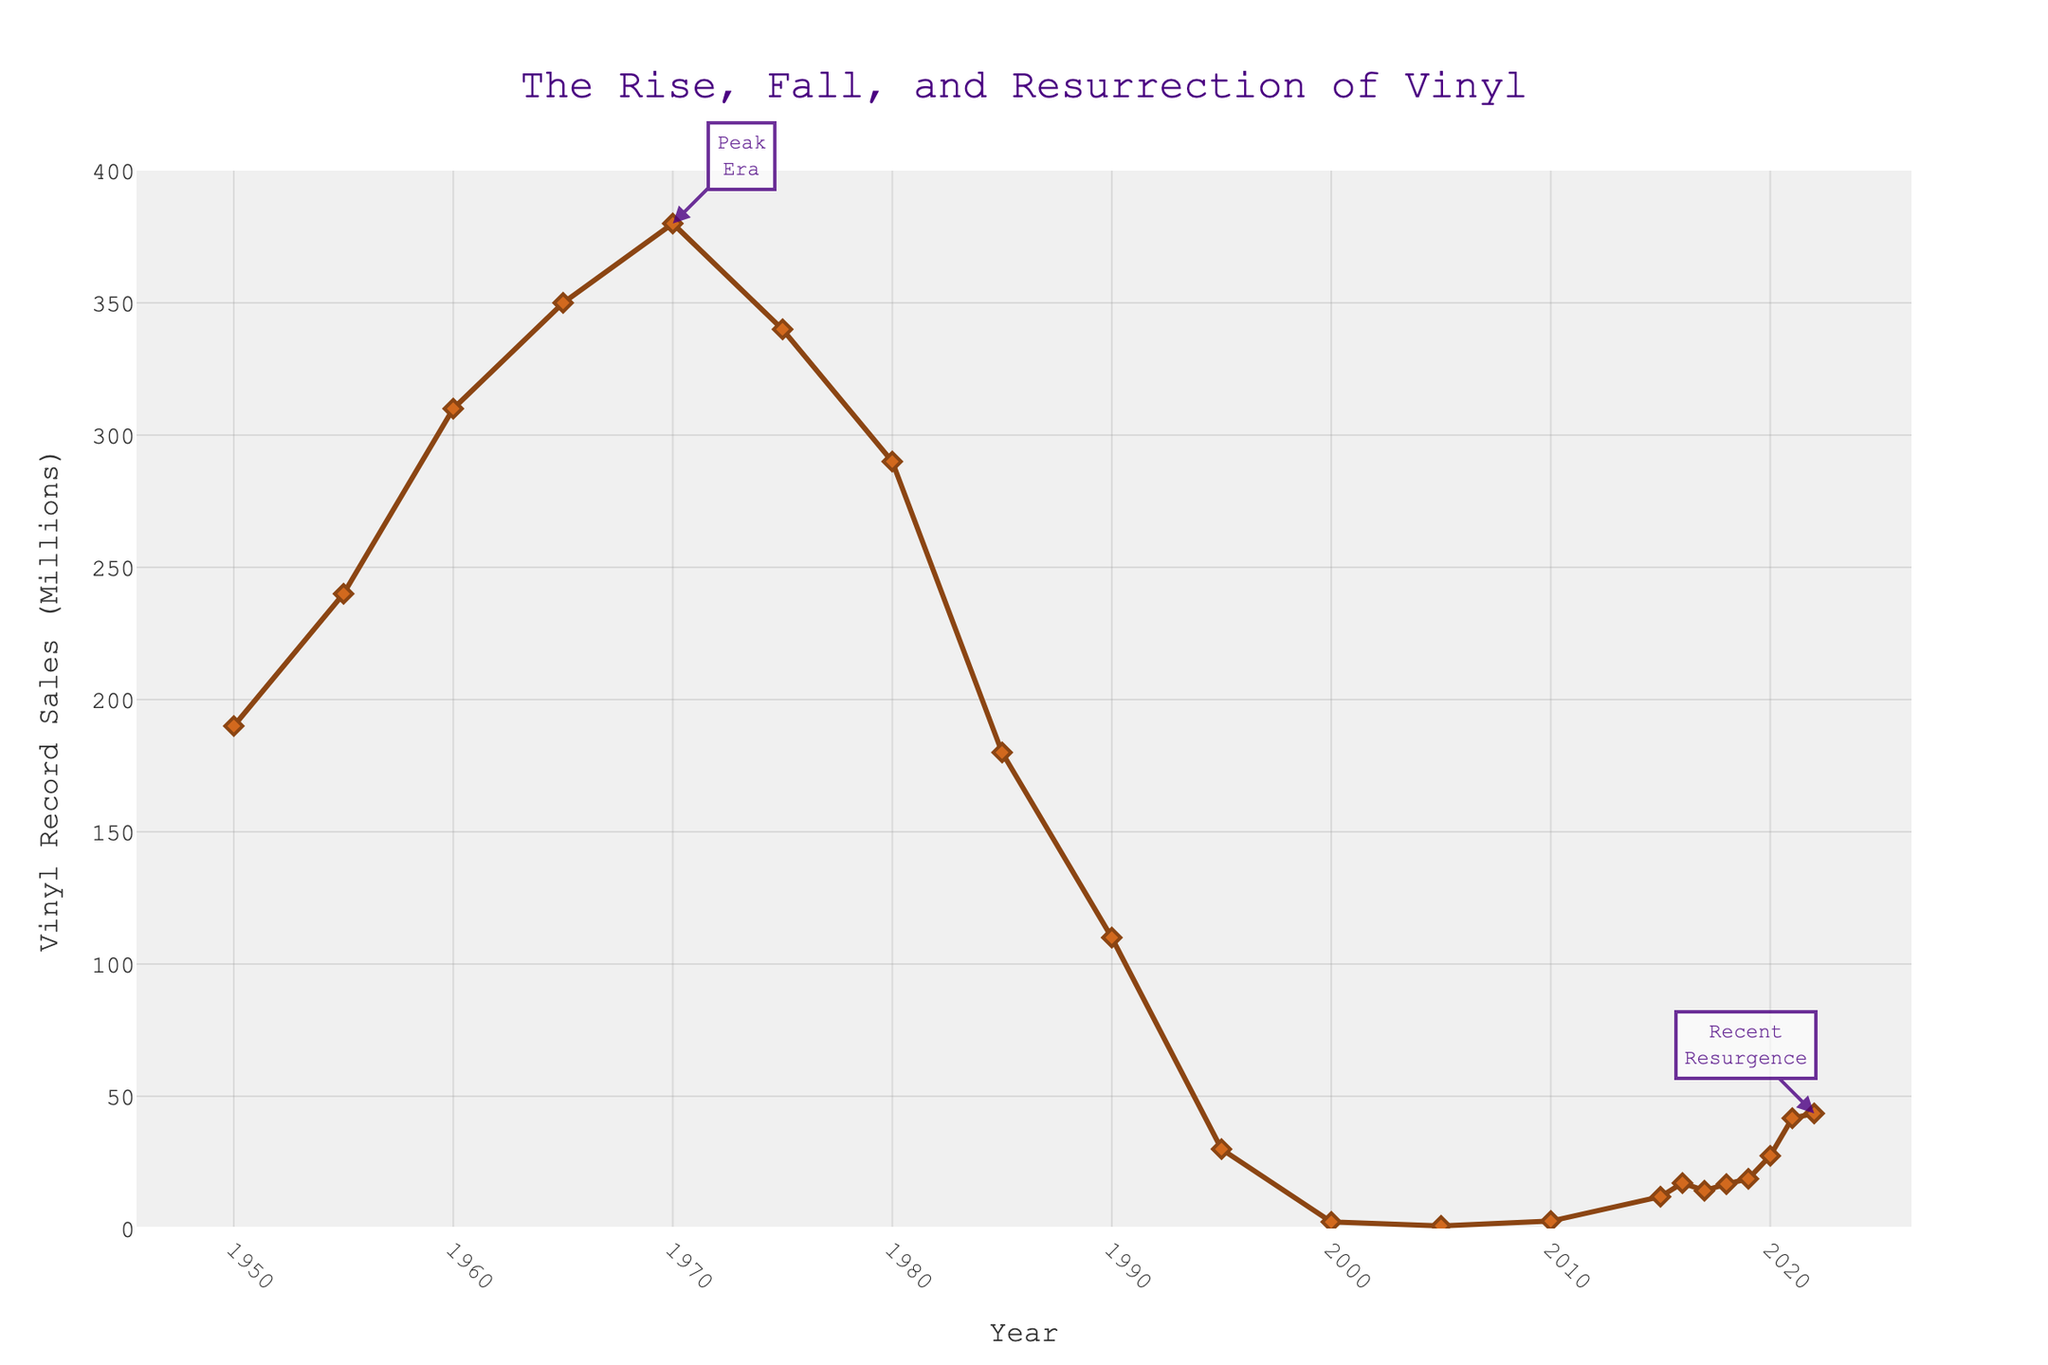What's the peak sales year on the chart? The highest point on the chart is around 1970. The annotation "Peak Era" also points to 1970, showing the maximum vinyl record sales.
Answer: 1970 What's the total decline in sales from the peak year to 2000? The peak is 380 million in 1970. By 2000, sales are at 2.5 million. The decline is calculated as 380 - 2.5 = 377.5 million.
Answer: 377.5 million Which year had higher sales: 1995 or 2010? By looking at the plot, we can see the value for 1995 is significantly higher than for 2010. In 1995, the sales are 30 million, compared to 2010 when sales are only 2.8 million.
Answer: 1995 How many years did sales remain below 10 million after 1985? From 1985 onwards, sales were below 10 million in 1990, 1995, 2000, 2005, and 2010. This gives a total of 5 years.
Answer: 5 years What is the approximate average vinyl sales from 1985 to 2005? Sales for the respective years are: 1985 (180 million), 1990 (110 million), 1995 (30 million), 2000 (2.5 million), and 2005 (1 million). The sum is 180 + 110 + 30 + 2.5 + 1 = 323.5. The average is 323.5 / 5 = 64.7 million.
Answer: 64.7 million What trend is observed in vinyl sales from 2000 to 2022? Vinyl sales start very low at 2.5 million in 2000 and increase steadily, reaching 43.5 million in 2022. The overall trend can be described as a resurgence.
Answer: Resurgence Which decade experienced the most significant drop in vinyl sales? The steepest decline is observed between 1970 and 1980, where sales dropped from 380 million to 290 million.
Answer: 1970-1980 Compare the vinyl sales in the two annotation points, 1970 and 2022. Sales were at their peak in 1970 with 380 million records and resurged to 43.5 million in 2022. Clearly, 1970 had much higher sales than 2022.
Answer: 1970 had higher sales Describe the vinyl market trend from 1950 to 1980. From 1950 to 1980, vinyl sales generally increased, reaching a peak in 1970 at 380 million, followed by a decline to 290 million in 1980.
Answer: Rising then declining What was the percentage increase in vinyl sales from 2020 to 2021? Sales in 2020 were 27.5 million and in 2021 it was 41.7 million. The increase is 41.7 - 27.5 = 14.2 million. To find the percentage: (14.2 / 27.5) * 100 = 51.64%.
Answer: 51.64% 